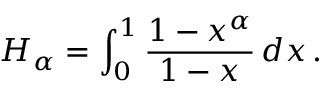<formula> <loc_0><loc_0><loc_500><loc_500>H _ { \alpha } = \int _ { 0 } ^ { 1 } { \frac { 1 - x ^ { \alpha } } { 1 - x } } \, d x \, .</formula> 